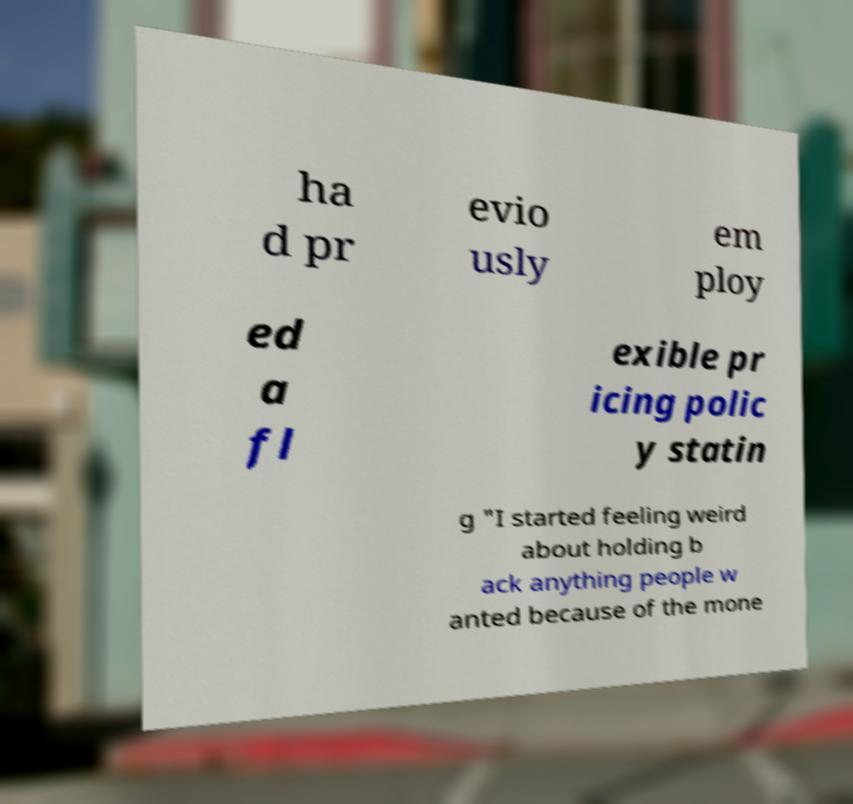There's text embedded in this image that I need extracted. Can you transcribe it verbatim? ha d pr evio usly em ploy ed a fl exible pr icing polic y statin g "I started feeling weird about holding b ack anything people w anted because of the mone 